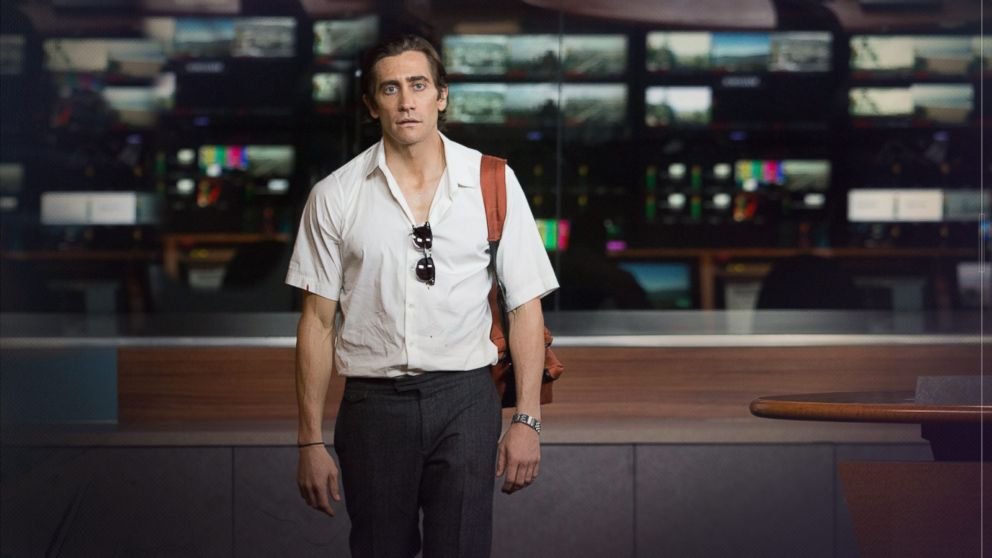What does the character's environment and attire suggest about his profession or role in the story? The environment, filled with broadcasting screens and equipment, indicates that the character is in a newsroom, suggesting a role related to journalism or media. His attire, slightly casual but still neat, mirrors the often gritty, on-the-go lifestyle of a news journalist, especially one who might cover night-time events, reflecting the movie 'Nightcrawler's' exploration of crime journalism. 